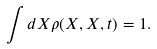<formula> <loc_0><loc_0><loc_500><loc_500>\int d X \rho ( X , X , t ) = 1 .</formula> 